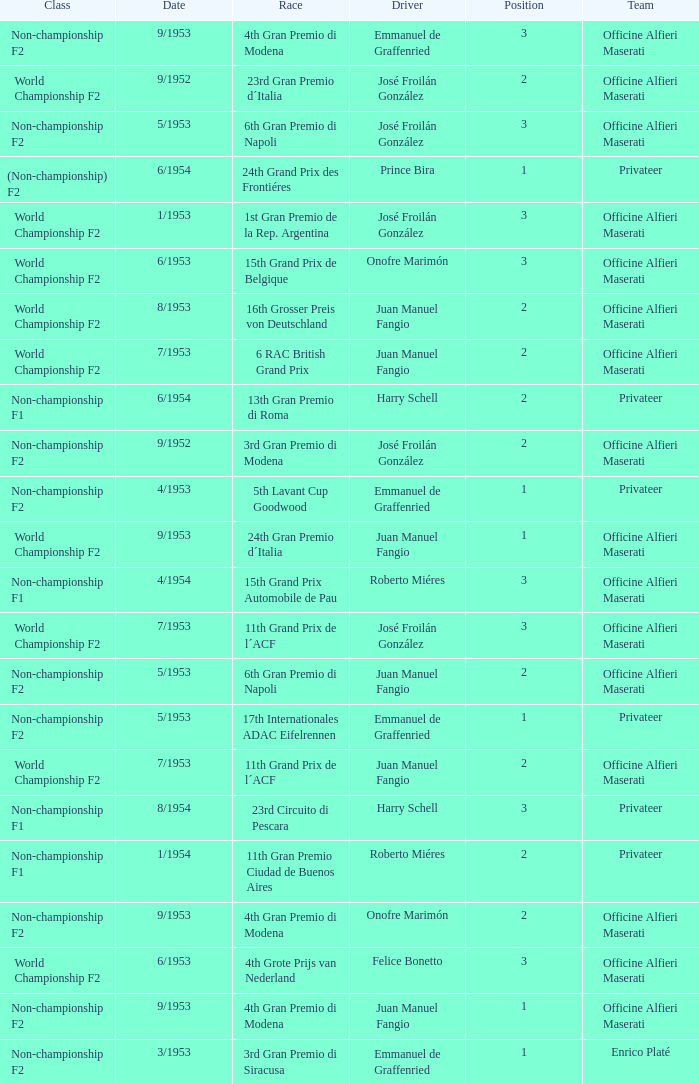What date has the class of non-championship f2 as well as a driver name josé froilán gonzález that has a position larger than 2? 5/1953. 